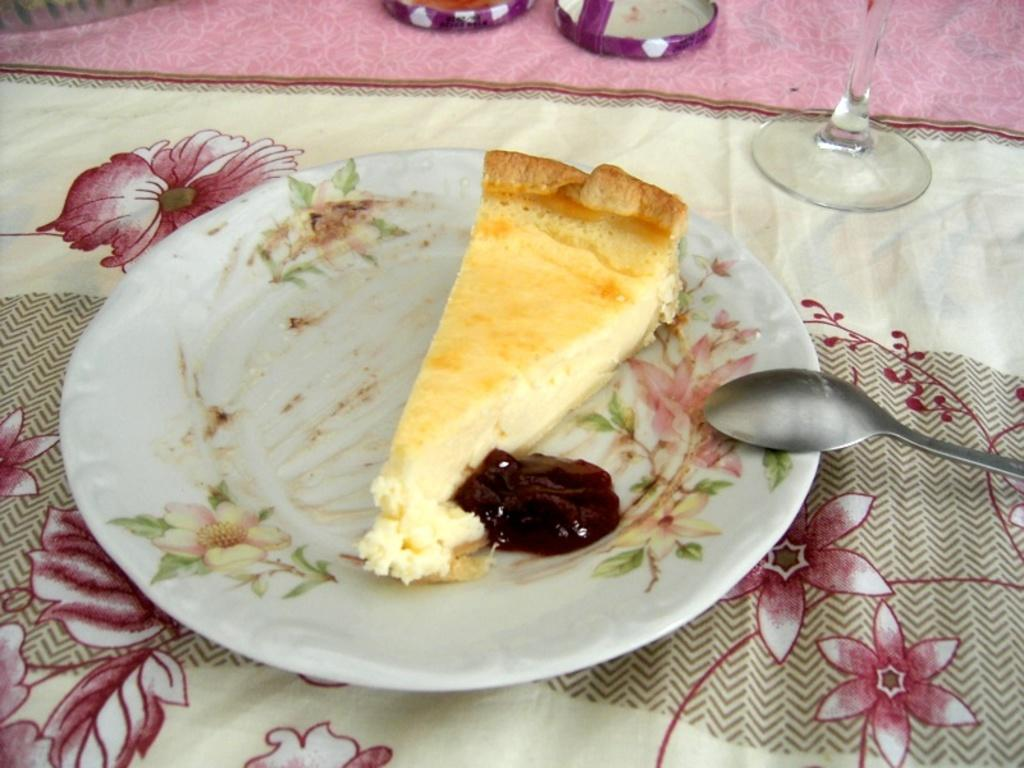What type of food is visible in the image? There is a cake piece in the image. What accompanies the cake piece? There is sauce in the image. Where are the cake piece and sauce located? The cake piece and sauce are in a plate. What utensil is present in the image? There is a spoon in the image. What beverage container is visible? There is a glass in the image. What type of surface is the cake, sauce, spoon, and glass placed on? There are objects on a cloth in the image. What type of quartz is used as a decoration on the cake in the image? There is no quartz present in the image, and the cake does not have any decorations mentioned. How does the soup in the image affect the taste of the cake? There is no soup present in the image; it only features a cake piece and sauce. 